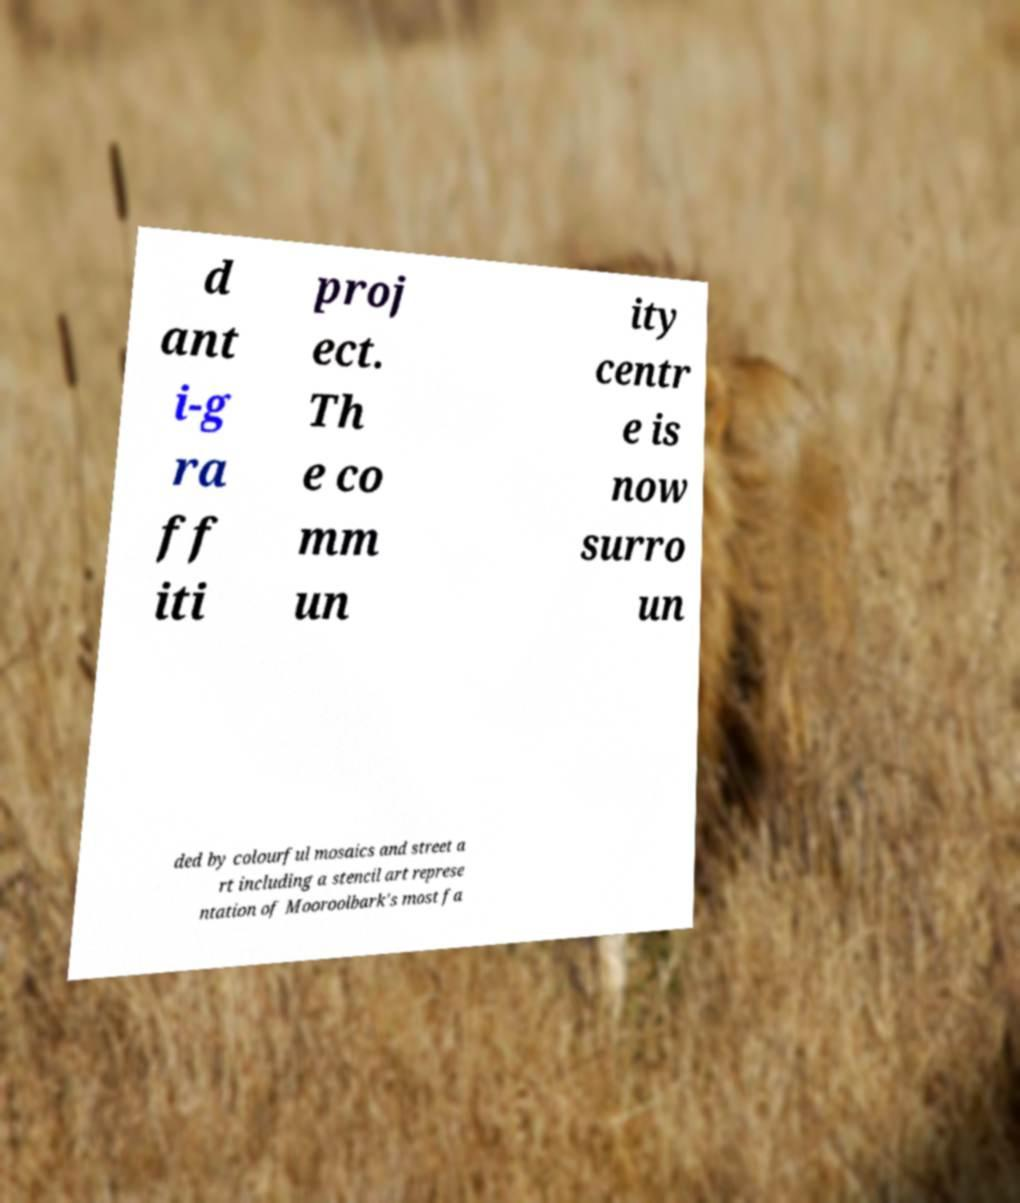Please read and relay the text visible in this image. What does it say? d ant i-g ra ff iti proj ect. Th e co mm un ity centr e is now surro un ded by colourful mosaics and street a rt including a stencil art represe ntation of Mooroolbark's most fa 